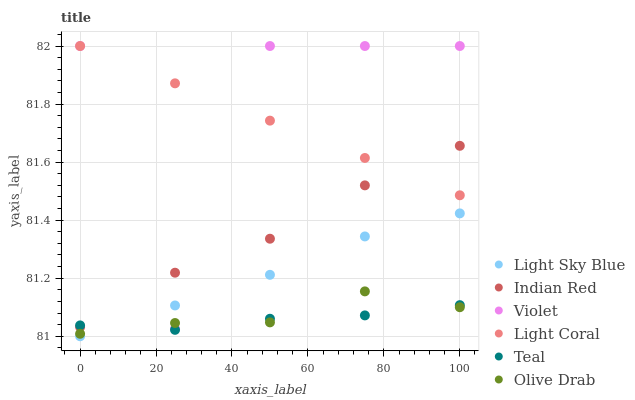Does Teal have the minimum area under the curve?
Answer yes or no. Yes. Does Violet have the maximum area under the curve?
Answer yes or no. Yes. Does Light Coral have the minimum area under the curve?
Answer yes or no. No. Does Light Coral have the maximum area under the curve?
Answer yes or no. No. Is Light Coral the smoothest?
Answer yes or no. Yes. Is Violet the roughest?
Answer yes or no. Yes. Is Light Sky Blue the smoothest?
Answer yes or no. No. Is Light Sky Blue the roughest?
Answer yes or no. No. Does Light Sky Blue have the lowest value?
Answer yes or no. Yes. Does Light Coral have the lowest value?
Answer yes or no. No. Does Violet have the highest value?
Answer yes or no. Yes. Does Light Sky Blue have the highest value?
Answer yes or no. No. Is Light Sky Blue less than Light Coral?
Answer yes or no. Yes. Is Light Coral greater than Olive Drab?
Answer yes or no. Yes. Does Light Sky Blue intersect Violet?
Answer yes or no. Yes. Is Light Sky Blue less than Violet?
Answer yes or no. No. Is Light Sky Blue greater than Violet?
Answer yes or no. No. Does Light Sky Blue intersect Light Coral?
Answer yes or no. No. 